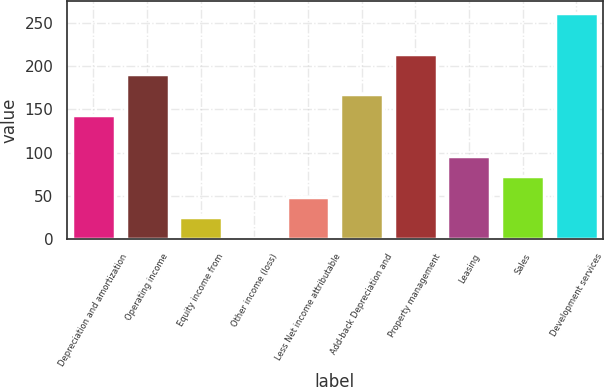Convert chart to OTSL. <chart><loc_0><loc_0><loc_500><loc_500><bar_chart><fcel>Depreciation and amortization<fcel>Operating income<fcel>Equity income from<fcel>Other income (loss)<fcel>Less Net income attributable<fcel>Add-back Depreciation and<fcel>Property management<fcel>Leasing<fcel>Sales<fcel>Development services<nl><fcel>143.5<fcel>190.9<fcel>25<fcel>1.3<fcel>48.7<fcel>167.2<fcel>214.6<fcel>96.1<fcel>72.4<fcel>262<nl></chart> 